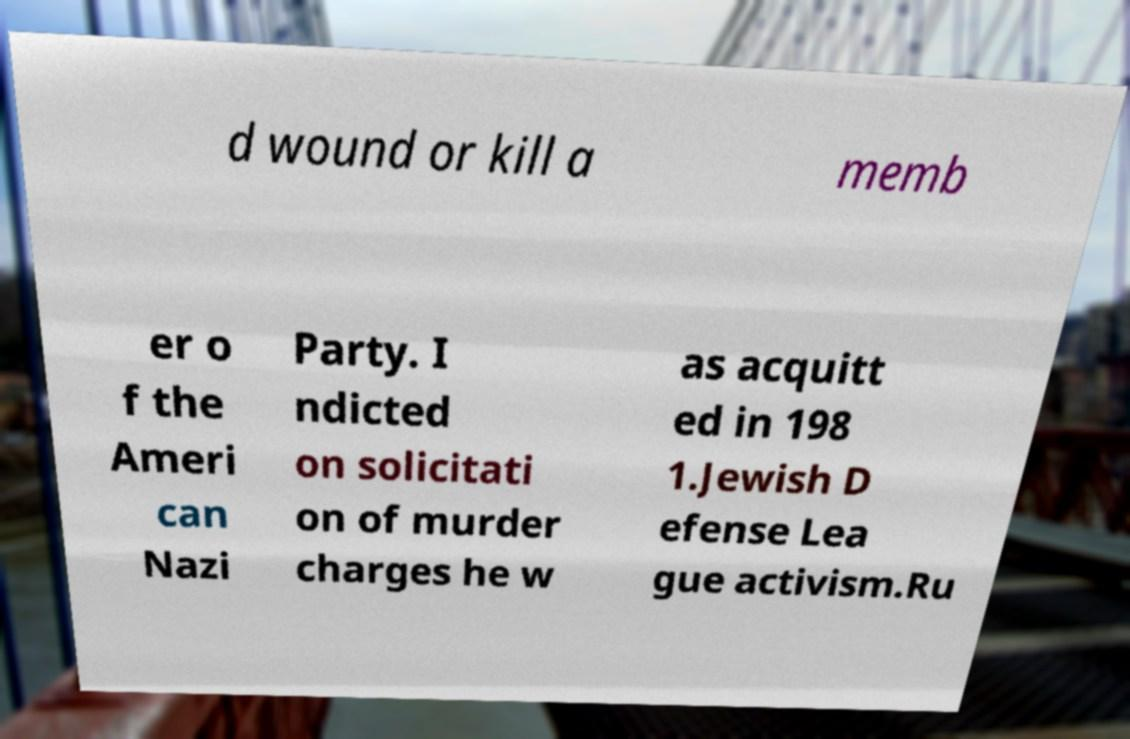Could you extract and type out the text from this image? d wound or kill a memb er o f the Ameri can Nazi Party. I ndicted on solicitati on of murder charges he w as acquitt ed in 198 1.Jewish D efense Lea gue activism.Ru 